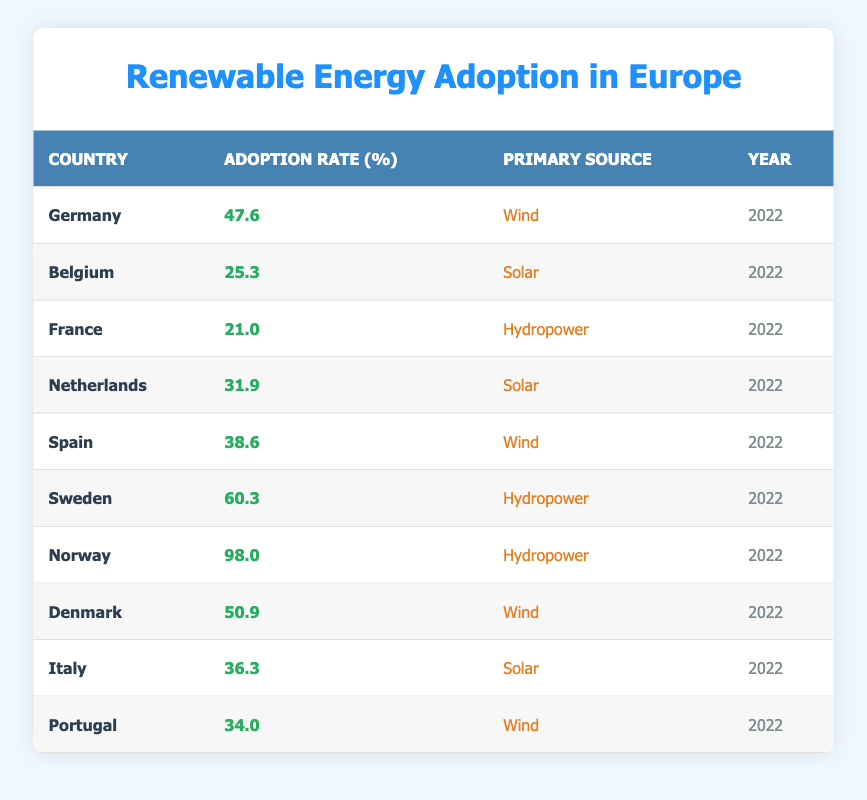What is the adoption rate of renewable energy in Norway? According to the table, Norway has an adoption rate of 98.0 percent, which is the highest among all listed countries.
Answer: 98.0 Which country has the lowest renewable energy adoption rate? From the data, France has the lowest adoption rate at 21.0 percent.
Answer: France What is the average adoption rate of renewable energy for the following countries: Belgium, Netherlands, and Spain? The adoption rates for these countries are Belgium (25.3), Netherlands (31.9), and Spain (38.6). The average is calculated as (25.3 + 31.9 + 38.6) / 3 = 31.933, rounded to one decimal place, gives 31.9.
Answer: 31.9 True or False: Italy's primary source of renewable energy is wind. Based on the table, Italy's primary source of renewable energy is solar, not wind, therefore the statement is false.
Answer: False Which country has a higher adoption rate: Denmark or Germany? Denmark has an adoption rate of 50.9 percent, while Germany has an adoption rate of 47.6 percent. Since 50.9 is greater than 47.6, Denmark has a higher adoption rate.
Answer: Denmark How many countries have renewable energy adoption rates above 40 percent? The countries with adoption rates above 40 percent are Germany (47.6), Denmark (50.9), Sweden (60.3), and Norway (98.0). This gives a total of four countries.
Answer: 4 What percentage points higher is Sweden's adoption rate compared to France's? Sweden has an adoption rate of 60.3 percent, while France has an adoption rate of 21.0 percent. The difference can be calculated as 60.3 - 21.0 = 39.3 percentage points.
Answer: 39.3 Which countries primarily utilize wind as a source of renewable energy? Reviewing the table, Germany, Spain, Denmark, and Portugal use wind as their primary source of renewable energy.
Answer: Germany, Spain, Denmark, Portugal What is the total adoption rate of renewable energy for all countries in the table? To find the total adoption rate, we must sum each country's adoption rate: 47.6 + 25.3 + 21.0 + 31.9 + 38.6 + 60.3 + 98.0 + 50.9 + 36.3 + 34.0 = 394.9. Therefore, the total adoption rate of renewable energy is 394.9 percent.
Answer: 394.9 